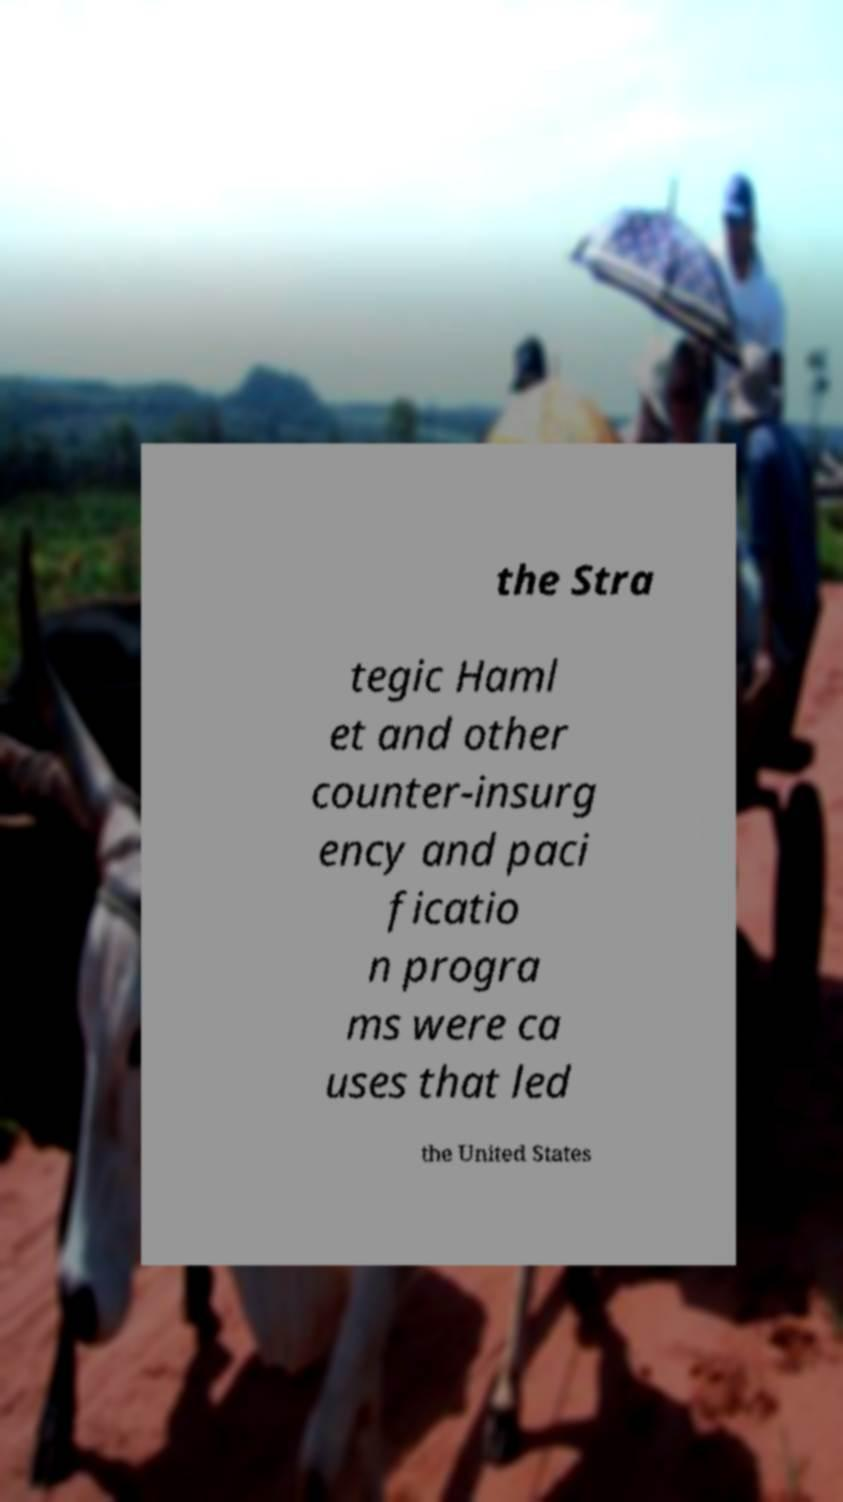Can you accurately transcribe the text from the provided image for me? the Stra tegic Haml et and other counter-insurg ency and paci ficatio n progra ms were ca uses that led the United States 